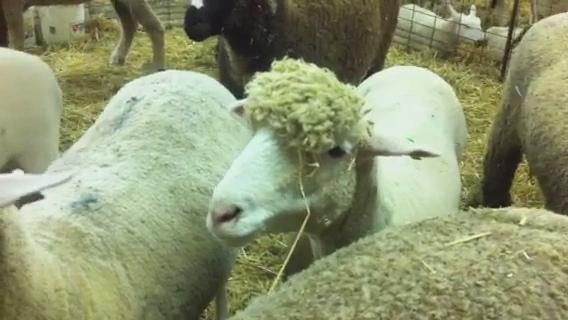What does the fur resemble? Please explain your reasoning. hat. The hair is covering the sheep's head and shading its eyes. 